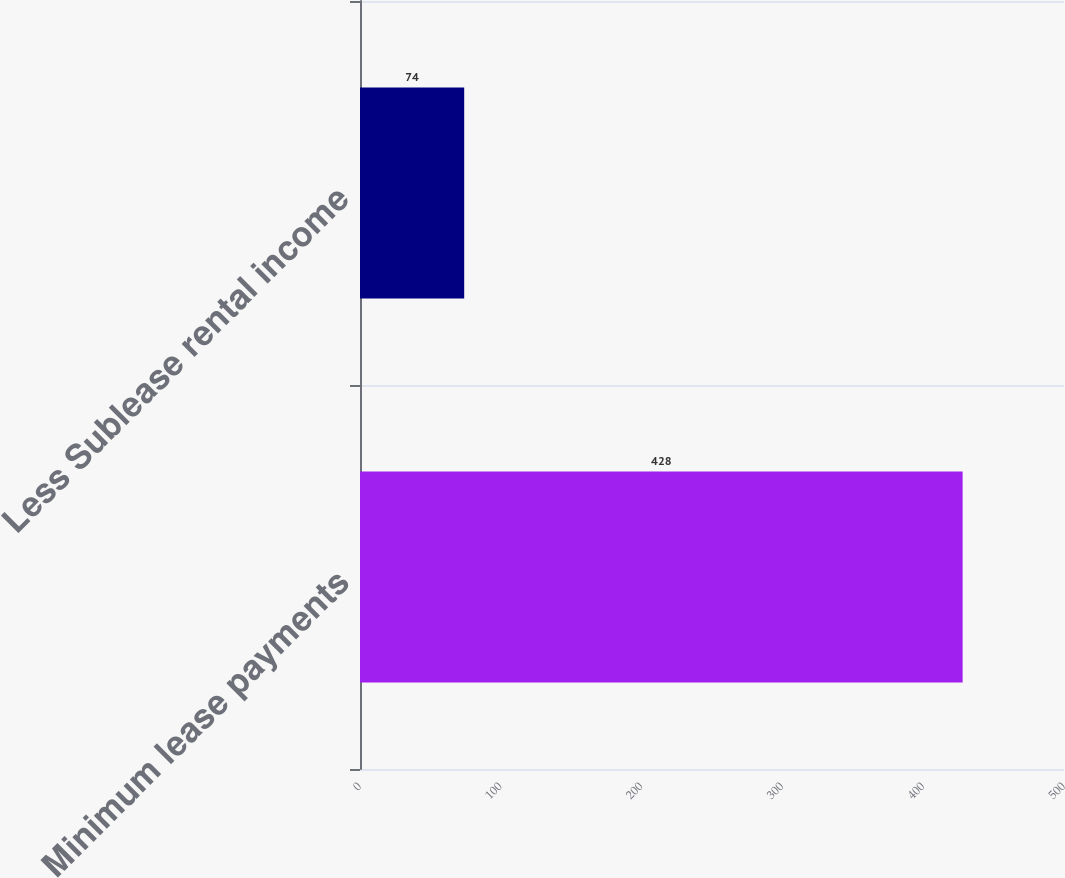Convert chart to OTSL. <chart><loc_0><loc_0><loc_500><loc_500><bar_chart><fcel>Minimum lease payments<fcel>Less Sublease rental income<nl><fcel>428<fcel>74<nl></chart> 